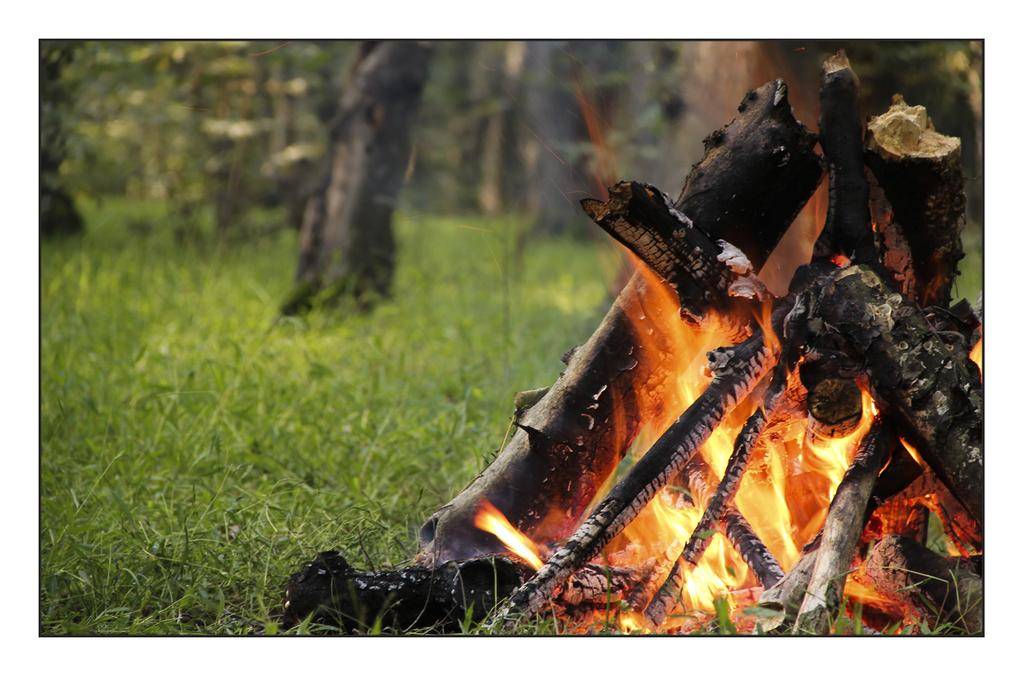What type of vegetation is present in the image? There is grass in the image. What other natural elements can be seen in the image? There are trees in the image, with their tops truncated. What man-made object is present in the image? There is wood in the image, with its right side truncated. What is the source of heat or light in the image? There is fire in the image. How many legs can be seen on the army in the image? There is no army present in the image, so there are no legs to count. 